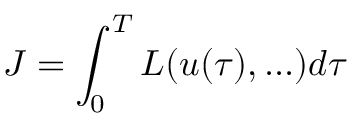Convert formula to latex. <formula><loc_0><loc_0><loc_500><loc_500>J = \int _ { 0 } ^ { T } L ( u ( \tau ) , \dots ) d \tau</formula> 